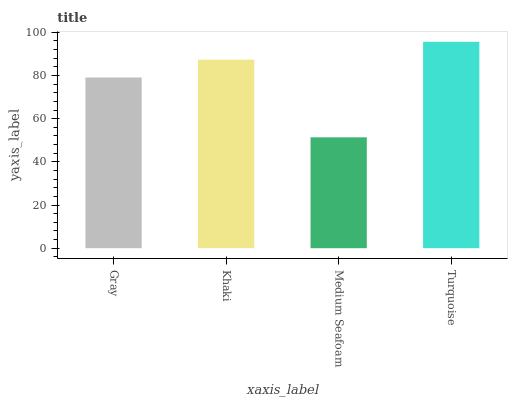Is Medium Seafoam the minimum?
Answer yes or no. Yes. Is Turquoise the maximum?
Answer yes or no. Yes. Is Khaki the minimum?
Answer yes or no. No. Is Khaki the maximum?
Answer yes or no. No. Is Khaki greater than Gray?
Answer yes or no. Yes. Is Gray less than Khaki?
Answer yes or no. Yes. Is Gray greater than Khaki?
Answer yes or no. No. Is Khaki less than Gray?
Answer yes or no. No. Is Khaki the high median?
Answer yes or no. Yes. Is Gray the low median?
Answer yes or no. Yes. Is Gray the high median?
Answer yes or no. No. Is Khaki the low median?
Answer yes or no. No. 